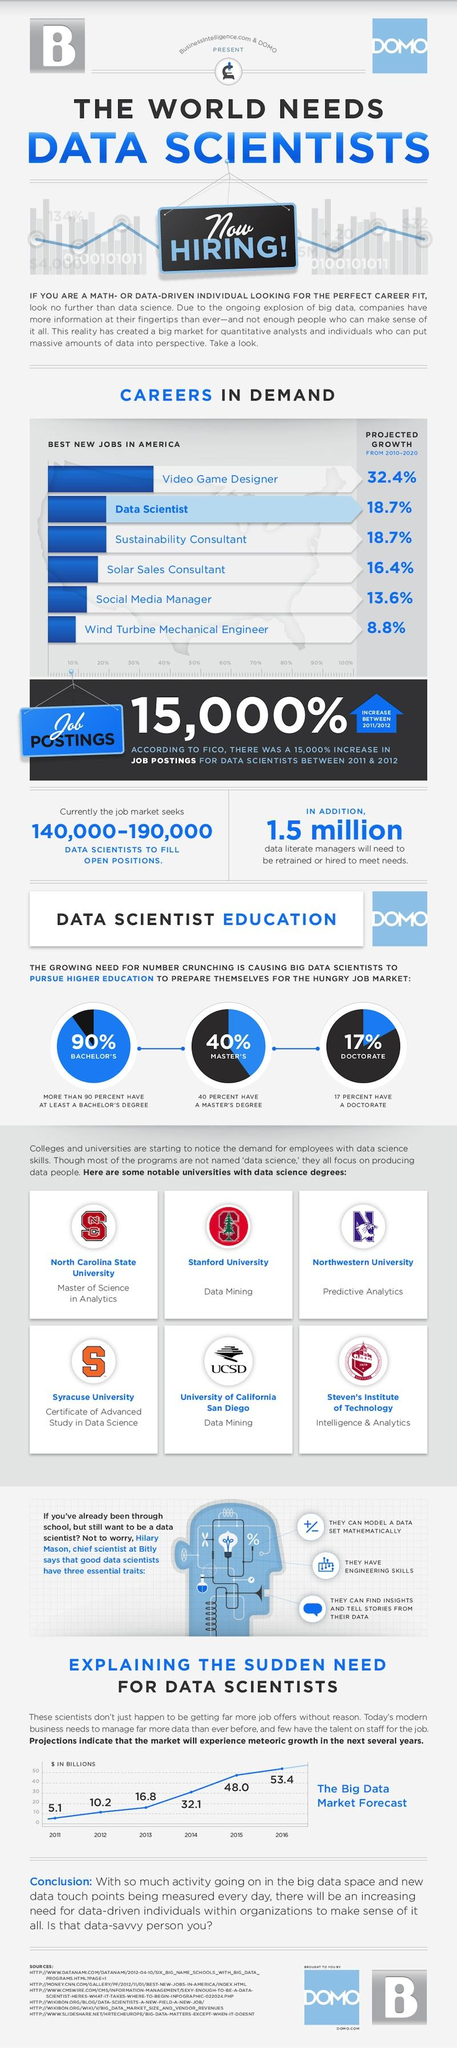Give some essential details in this illustration. There are currently two universities offering data mining courses. In 2016, there was an increase of approximately 5.4 billion data scientists compared to 2015. During the period of 2010-2020, the project growth of data scientists was comparable to that of sustainability consultants. According to the provided data, only 17% of big data scientists are pursuing PhDs. This is lower than the 40% who are pursuing master's degrees and the 90% who have at least a bachelor's degree. 